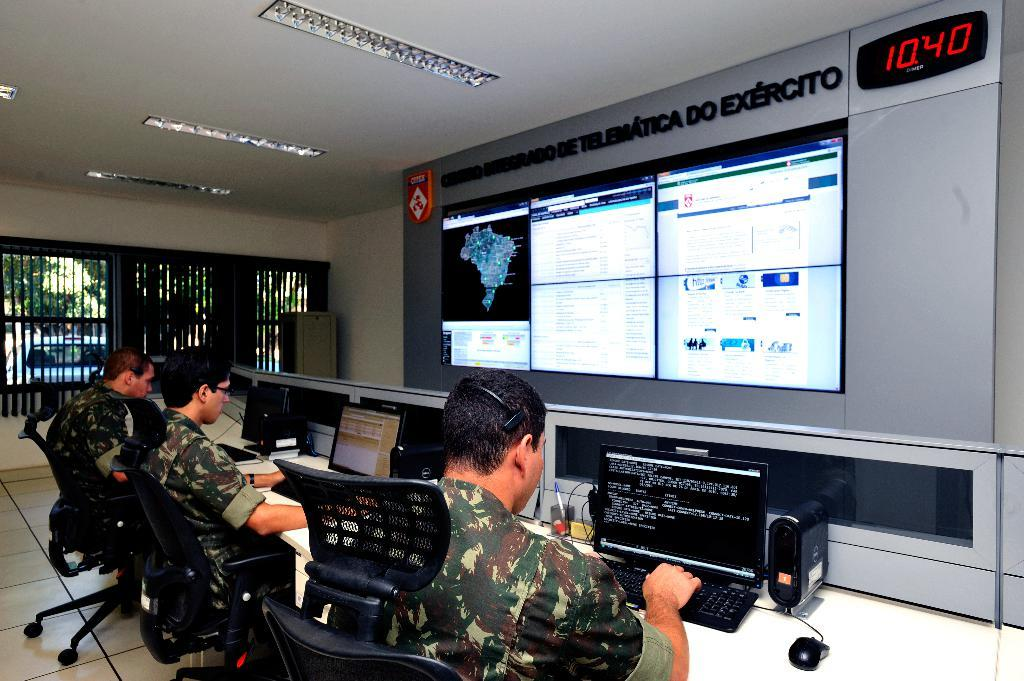<image>
Give a short and clear explanation of the subsequent image. people in military uniform in front of monitors and sign reading Exercito 